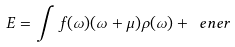<formula> <loc_0><loc_0><loc_500><loc_500>E = \int f ( \omega ) ( \omega + \mu ) \rho ( \omega ) + \ e n e r</formula> 